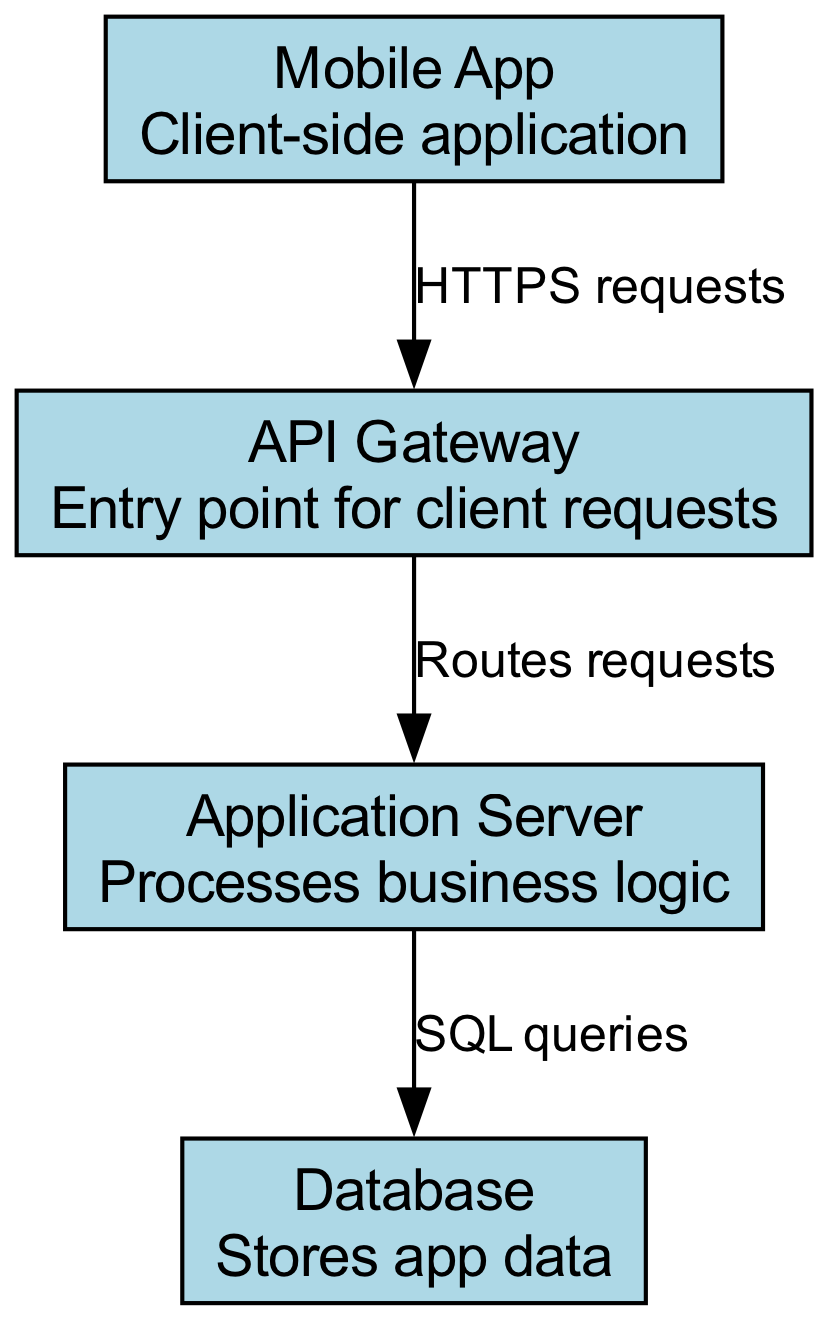What is the entry point for client requests? The diagram shows that the API Gateway is labeled as the entry point for client requests, which is connected to the Mobile App.
Answer: API Gateway How many nodes are present in the diagram? By counting the different labeled components in the diagram, we find there are four nodes: Mobile App, API Gateway, Application Server, and Database.
Answer: 4 What type of requests does the Mobile App send? The diagram indicates that the Mobile App sends HTTPS requests to the API Gateway, as labeled on the connecting edge.
Answer: HTTPS requests Which component processes business logic? The Application Server is clearly labeled in the diagram as the component that processes business logic, linking it to the API Gateway.
Answer: Application Server How do requests flow from the Mobile App to the Database? The flow starts with the Mobile App sending HTTPS requests to the API Gateway, which routes these requests to the Application Server, where SQL queries are made to interact with the Database.
Answer: HTTPS requests → Routes requests → SQL queries What kind of queries does the Application Server perform? The diagram states that the Application Server performs SQL queries, which are linked to the Database node.
Answer: SQL queries Which node directly interacts with the Database? The Application Server directly interacts with the Database, as indicated by the edge labeled SQL queries connecting the two nodes.
Answer: Application Server How many edges are present in the diagram? The diagram shows three edges that connect the four nodes, indicating the relationships and interactions among them.
Answer: 3 What is the connection type between the API Gateway and the Application Server? The connection between the API Gateway and the Application Server is labeled as "Routes requests," indicating how the API Gateway directs the requests.
Answer: Routes requests 